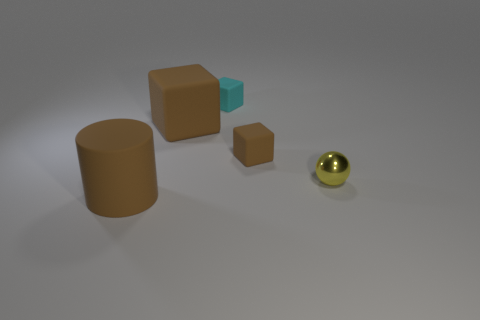What is the color of the small rubber thing that is behind the small brown cube?
Offer a very short reply. Cyan. There is a object that is behind the small metallic object and left of the cyan block; what is its material?
Provide a short and direct response. Rubber. How many metallic spheres are left of the brown object on the left side of the large brown block?
Offer a very short reply. 0. What is the shape of the tiny brown matte thing?
Ensure brevity in your answer.  Cube. There is a small brown thing that is the same material as the cylinder; what shape is it?
Keep it short and to the point. Cube. Do the large brown rubber thing that is on the left side of the large block and the tiny cyan matte thing have the same shape?
Your answer should be compact. No. What is the shape of the small object that is to the left of the small brown rubber block?
Give a very brief answer. Cube. There is a small thing that is the same color as the cylinder; what shape is it?
Offer a very short reply. Cube. How many matte blocks have the same size as the cyan rubber thing?
Make the answer very short. 1. The cylinder is what color?
Provide a short and direct response. Brown. 